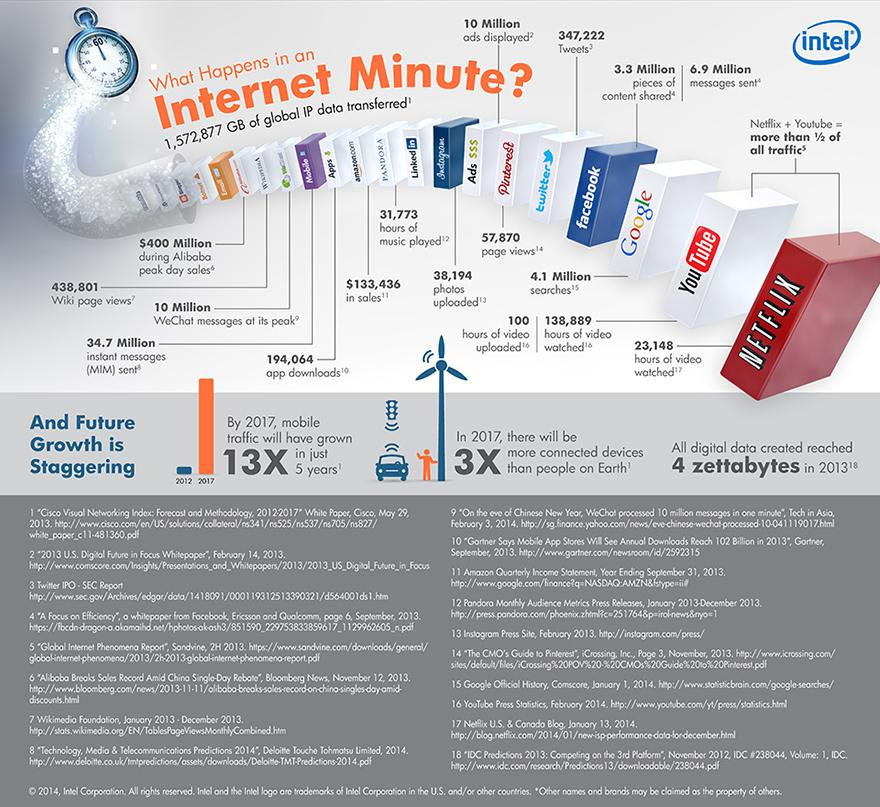Mention a couple of crucial points in this snapshot. As of now, there have been 194,064 app downloads. There are approximately 34.7 million instant messages in existence. According to a search on Google, there were approximately 4.1 million searches in the last month. As of 2021, there have been approximately 38,194 photos uploaded on Instagram. 